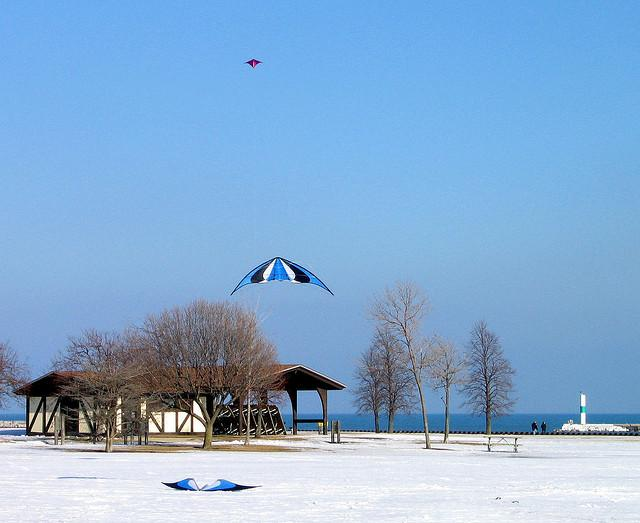The kites perform was motion in order to move across the sky? Please explain your reasoning. they glide. The wind lifts the material in a smooth motion. 